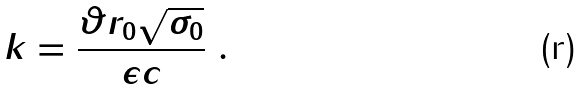<formula> <loc_0><loc_0><loc_500><loc_500>k = \frac { \vartheta r _ { 0 } \sqrt { \sigma _ { 0 } } } { \epsilon c } \ .</formula> 